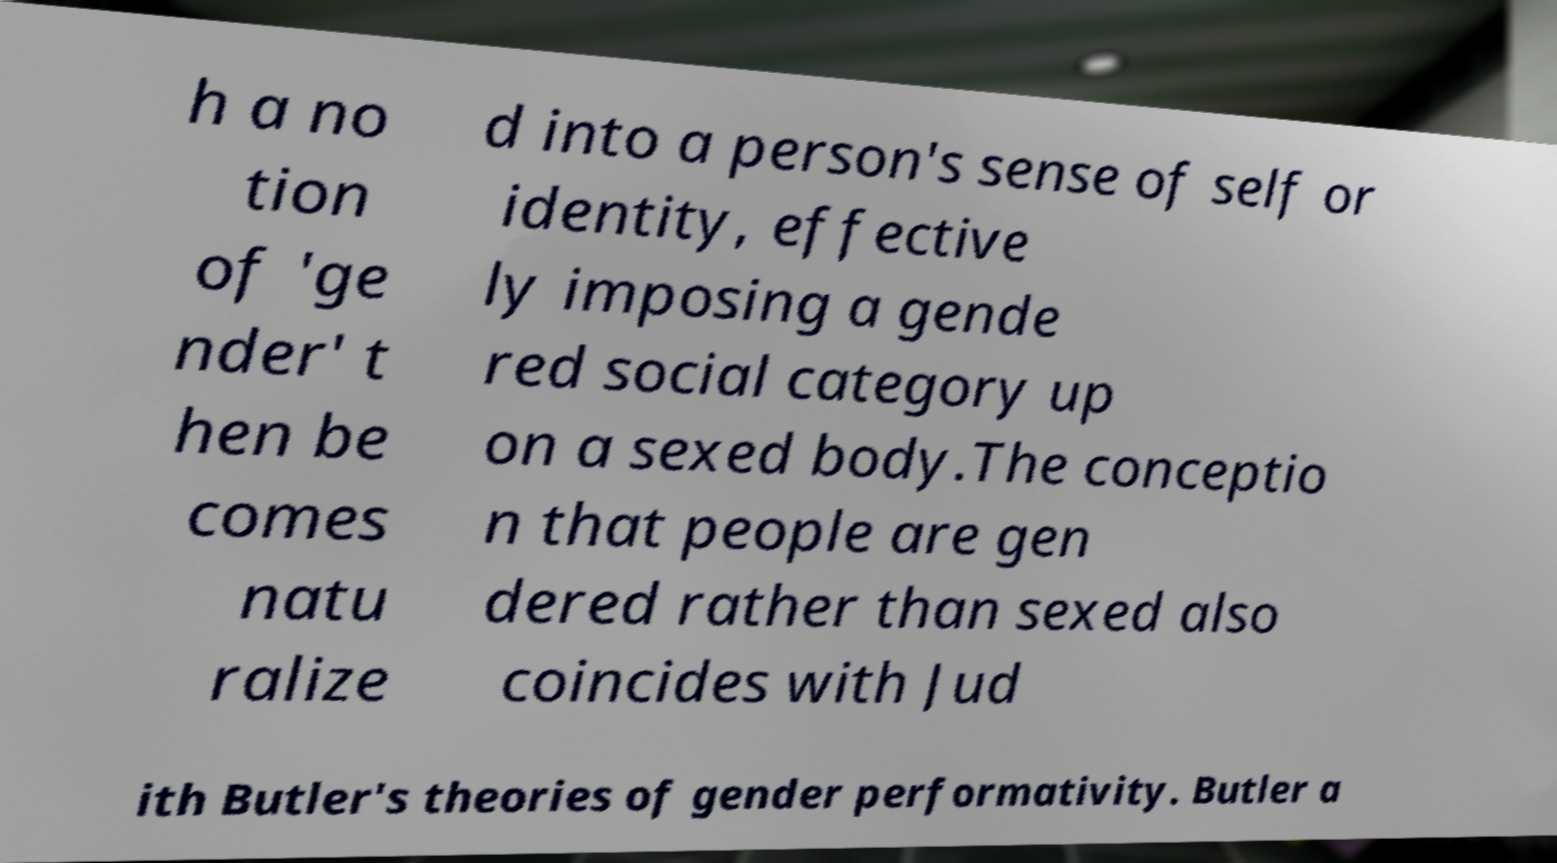Could you extract and type out the text from this image? h a no tion of 'ge nder' t hen be comes natu ralize d into a person's sense of self or identity, effective ly imposing a gende red social category up on a sexed body.The conceptio n that people are gen dered rather than sexed also coincides with Jud ith Butler's theories of gender performativity. Butler a 